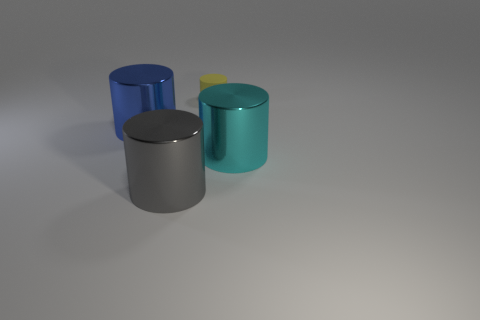Subtract all blue metallic cylinders. How many cylinders are left? 3 Subtract all cyan cylinders. How many cylinders are left? 3 Add 3 large blue cylinders. How many objects exist? 7 Add 3 tiny rubber things. How many tiny rubber things are left? 4 Add 1 green metal blocks. How many green metal blocks exist? 1 Subtract 0 blue balls. How many objects are left? 4 Subtract 3 cylinders. How many cylinders are left? 1 Subtract all gray cylinders. Subtract all green cubes. How many cylinders are left? 3 Subtract all small green things. Subtract all metallic objects. How many objects are left? 1 